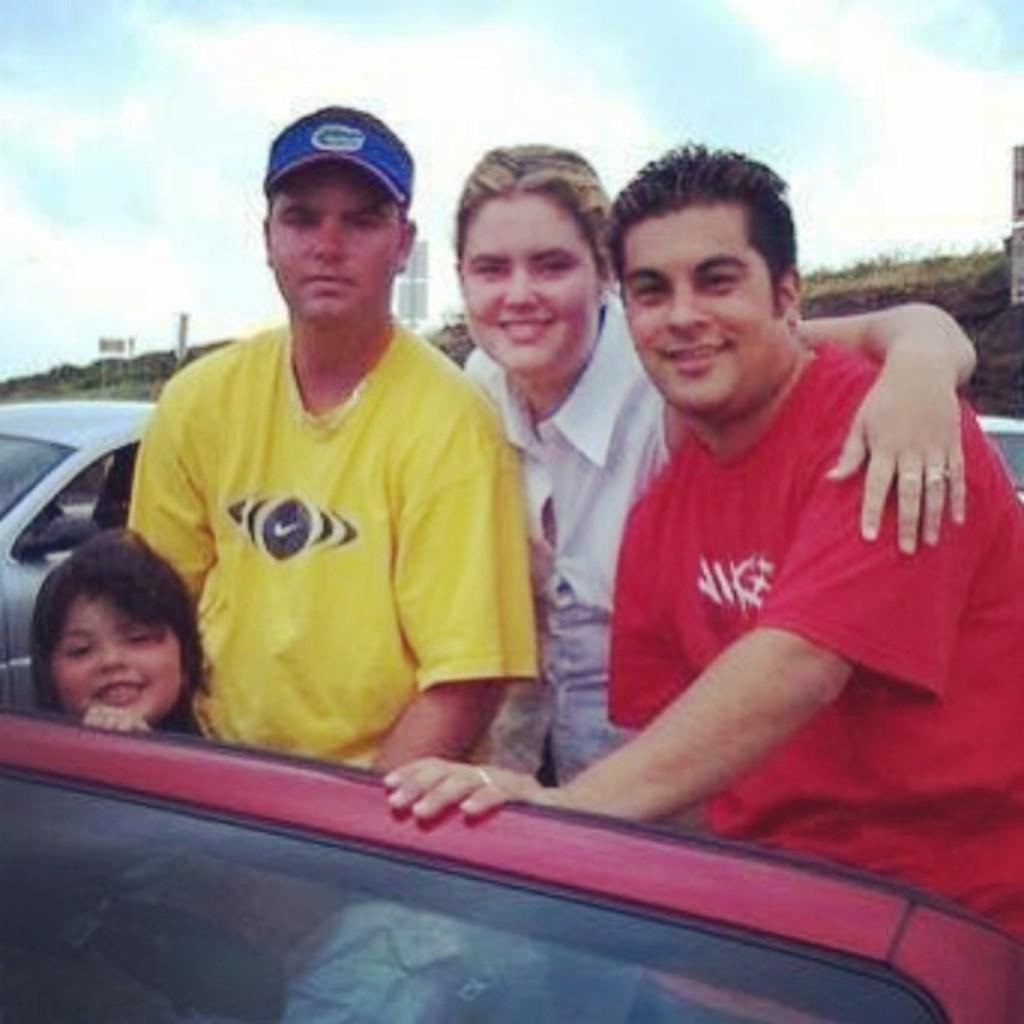How many people are present in the image? There are three people in the image. Can you describe the youngest person in the image? There is a kid in the image. Where are the three people and the kid located? They are standing inside a car. What type of car is visible in the background of the image? There is a white car in the background of the image. What type of bed can be seen in the image? There is no bed present in the image; it features three people and a kid standing inside a car. 